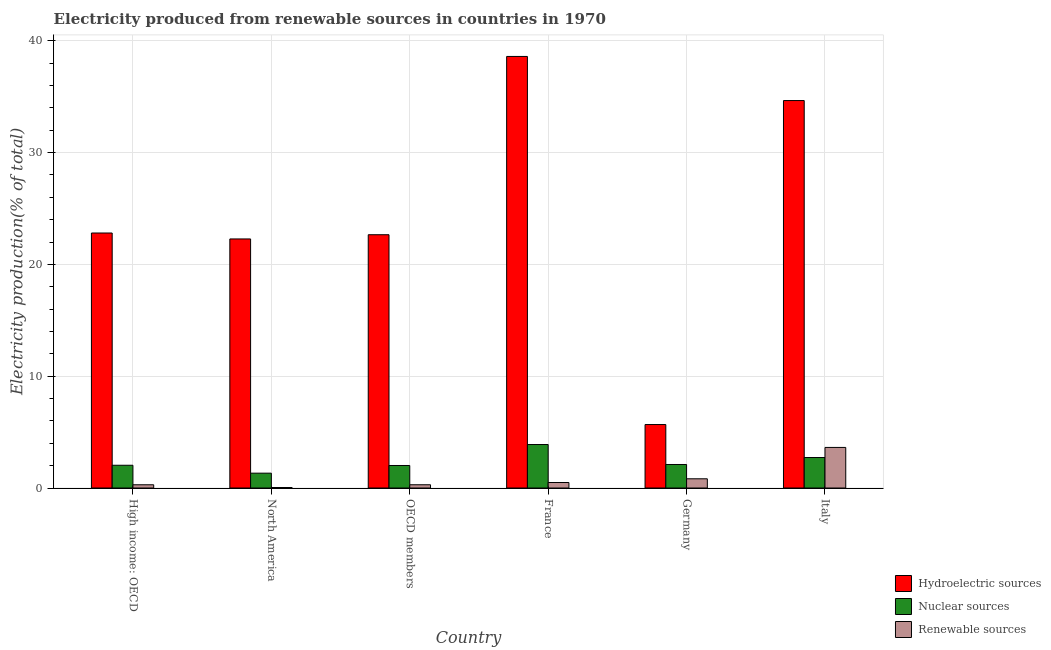How many bars are there on the 6th tick from the left?
Provide a succinct answer. 3. How many bars are there on the 1st tick from the right?
Your answer should be compact. 3. What is the label of the 4th group of bars from the left?
Provide a short and direct response. France. What is the percentage of electricity produced by hydroelectric sources in Germany?
Your answer should be compact. 5.68. Across all countries, what is the maximum percentage of electricity produced by nuclear sources?
Make the answer very short. 3.89. Across all countries, what is the minimum percentage of electricity produced by renewable sources?
Give a very brief answer. 0.04. In which country was the percentage of electricity produced by renewable sources minimum?
Offer a very short reply. North America. What is the total percentage of electricity produced by hydroelectric sources in the graph?
Provide a short and direct response. 146.67. What is the difference between the percentage of electricity produced by nuclear sources in Germany and that in High income: OECD?
Ensure brevity in your answer.  0.07. What is the difference between the percentage of electricity produced by nuclear sources in High income: OECD and the percentage of electricity produced by renewable sources in France?
Your answer should be very brief. 1.54. What is the average percentage of electricity produced by hydroelectric sources per country?
Ensure brevity in your answer.  24.45. What is the difference between the percentage of electricity produced by hydroelectric sources and percentage of electricity produced by renewable sources in High income: OECD?
Provide a succinct answer. 22.52. What is the ratio of the percentage of electricity produced by nuclear sources in France to that in Germany?
Your answer should be very brief. 1.85. Is the percentage of electricity produced by hydroelectric sources in Germany less than that in OECD members?
Ensure brevity in your answer.  Yes. Is the difference between the percentage of electricity produced by hydroelectric sources in France and OECD members greater than the difference between the percentage of electricity produced by nuclear sources in France and OECD members?
Ensure brevity in your answer.  Yes. What is the difference between the highest and the second highest percentage of electricity produced by renewable sources?
Your answer should be very brief. 2.81. What is the difference between the highest and the lowest percentage of electricity produced by hydroelectric sources?
Offer a terse response. 32.92. What does the 3rd bar from the left in High income: OECD represents?
Your answer should be compact. Renewable sources. What does the 2nd bar from the right in Germany represents?
Provide a short and direct response. Nuclear sources. Is it the case that in every country, the sum of the percentage of electricity produced by hydroelectric sources and percentage of electricity produced by nuclear sources is greater than the percentage of electricity produced by renewable sources?
Provide a succinct answer. Yes. How many bars are there?
Your answer should be very brief. 18. How many countries are there in the graph?
Provide a short and direct response. 6. Does the graph contain grids?
Provide a succinct answer. Yes. Where does the legend appear in the graph?
Your response must be concise. Bottom right. How many legend labels are there?
Provide a succinct answer. 3. What is the title of the graph?
Provide a short and direct response. Electricity produced from renewable sources in countries in 1970. Does "Resident buildings and public services" appear as one of the legend labels in the graph?
Your answer should be compact. No. What is the label or title of the Y-axis?
Offer a terse response. Electricity production(% of total). What is the Electricity production(% of total) in Hydroelectric sources in High income: OECD?
Your answer should be very brief. 22.81. What is the Electricity production(% of total) in Nuclear sources in High income: OECD?
Provide a short and direct response. 2.03. What is the Electricity production(% of total) in Renewable sources in High income: OECD?
Ensure brevity in your answer.  0.29. What is the Electricity production(% of total) in Hydroelectric sources in North America?
Offer a very short reply. 22.28. What is the Electricity production(% of total) of Nuclear sources in North America?
Provide a short and direct response. 1.33. What is the Electricity production(% of total) in Renewable sources in North America?
Your answer should be compact. 0.04. What is the Electricity production(% of total) in Hydroelectric sources in OECD members?
Give a very brief answer. 22.65. What is the Electricity production(% of total) of Nuclear sources in OECD members?
Provide a short and direct response. 2.01. What is the Electricity production(% of total) in Renewable sources in OECD members?
Ensure brevity in your answer.  0.29. What is the Electricity production(% of total) in Hydroelectric sources in France?
Offer a terse response. 38.6. What is the Electricity production(% of total) of Nuclear sources in France?
Offer a terse response. 3.89. What is the Electricity production(% of total) of Renewable sources in France?
Offer a terse response. 0.49. What is the Electricity production(% of total) of Hydroelectric sources in Germany?
Your answer should be very brief. 5.68. What is the Electricity production(% of total) in Nuclear sources in Germany?
Provide a succinct answer. 2.1. What is the Electricity production(% of total) of Renewable sources in Germany?
Ensure brevity in your answer.  0.82. What is the Electricity production(% of total) of Hydroelectric sources in Italy?
Keep it short and to the point. 34.66. What is the Electricity production(% of total) in Nuclear sources in Italy?
Your answer should be very brief. 2.73. What is the Electricity production(% of total) of Renewable sources in Italy?
Ensure brevity in your answer.  3.63. Across all countries, what is the maximum Electricity production(% of total) of Hydroelectric sources?
Make the answer very short. 38.6. Across all countries, what is the maximum Electricity production(% of total) of Nuclear sources?
Keep it short and to the point. 3.89. Across all countries, what is the maximum Electricity production(% of total) in Renewable sources?
Your answer should be compact. 3.63. Across all countries, what is the minimum Electricity production(% of total) of Hydroelectric sources?
Your answer should be compact. 5.68. Across all countries, what is the minimum Electricity production(% of total) of Nuclear sources?
Provide a short and direct response. 1.33. Across all countries, what is the minimum Electricity production(% of total) of Renewable sources?
Your answer should be very brief. 0.04. What is the total Electricity production(% of total) of Hydroelectric sources in the graph?
Offer a very short reply. 146.67. What is the total Electricity production(% of total) in Nuclear sources in the graph?
Provide a short and direct response. 14.1. What is the total Electricity production(% of total) in Renewable sources in the graph?
Offer a terse response. 5.57. What is the difference between the Electricity production(% of total) of Hydroelectric sources in High income: OECD and that in North America?
Give a very brief answer. 0.53. What is the difference between the Electricity production(% of total) of Nuclear sources in High income: OECD and that in North America?
Provide a succinct answer. 0.71. What is the difference between the Electricity production(% of total) in Renewable sources in High income: OECD and that in North America?
Provide a short and direct response. 0.24. What is the difference between the Electricity production(% of total) of Hydroelectric sources in High income: OECD and that in OECD members?
Offer a terse response. 0.15. What is the difference between the Electricity production(% of total) in Nuclear sources in High income: OECD and that in OECD members?
Make the answer very short. 0.02. What is the difference between the Electricity production(% of total) of Renewable sources in High income: OECD and that in OECD members?
Offer a terse response. -0. What is the difference between the Electricity production(% of total) in Hydroelectric sources in High income: OECD and that in France?
Your answer should be compact. -15.79. What is the difference between the Electricity production(% of total) of Nuclear sources in High income: OECD and that in France?
Your answer should be very brief. -1.86. What is the difference between the Electricity production(% of total) in Renewable sources in High income: OECD and that in France?
Keep it short and to the point. -0.2. What is the difference between the Electricity production(% of total) of Hydroelectric sources in High income: OECD and that in Germany?
Make the answer very short. 17.13. What is the difference between the Electricity production(% of total) of Nuclear sources in High income: OECD and that in Germany?
Your answer should be very brief. -0.07. What is the difference between the Electricity production(% of total) of Renewable sources in High income: OECD and that in Germany?
Ensure brevity in your answer.  -0.53. What is the difference between the Electricity production(% of total) of Hydroelectric sources in High income: OECD and that in Italy?
Offer a terse response. -11.85. What is the difference between the Electricity production(% of total) of Nuclear sources in High income: OECD and that in Italy?
Offer a terse response. -0.69. What is the difference between the Electricity production(% of total) in Renewable sources in High income: OECD and that in Italy?
Give a very brief answer. -3.34. What is the difference between the Electricity production(% of total) of Hydroelectric sources in North America and that in OECD members?
Your response must be concise. -0.38. What is the difference between the Electricity production(% of total) in Nuclear sources in North America and that in OECD members?
Offer a very short reply. -0.69. What is the difference between the Electricity production(% of total) in Renewable sources in North America and that in OECD members?
Provide a short and direct response. -0.25. What is the difference between the Electricity production(% of total) in Hydroelectric sources in North America and that in France?
Provide a short and direct response. -16.32. What is the difference between the Electricity production(% of total) in Nuclear sources in North America and that in France?
Ensure brevity in your answer.  -2.56. What is the difference between the Electricity production(% of total) in Renewable sources in North America and that in France?
Your answer should be compact. -0.45. What is the difference between the Electricity production(% of total) of Hydroelectric sources in North America and that in Germany?
Offer a very short reply. 16.6. What is the difference between the Electricity production(% of total) in Nuclear sources in North America and that in Germany?
Provide a succinct answer. -0.78. What is the difference between the Electricity production(% of total) of Renewable sources in North America and that in Germany?
Offer a terse response. -0.78. What is the difference between the Electricity production(% of total) of Hydroelectric sources in North America and that in Italy?
Provide a short and direct response. -12.38. What is the difference between the Electricity production(% of total) in Nuclear sources in North America and that in Italy?
Offer a terse response. -1.4. What is the difference between the Electricity production(% of total) of Renewable sources in North America and that in Italy?
Keep it short and to the point. -3.58. What is the difference between the Electricity production(% of total) of Hydroelectric sources in OECD members and that in France?
Your answer should be very brief. -15.95. What is the difference between the Electricity production(% of total) of Nuclear sources in OECD members and that in France?
Offer a very short reply. -1.88. What is the difference between the Electricity production(% of total) in Renewable sources in OECD members and that in France?
Offer a very short reply. -0.2. What is the difference between the Electricity production(% of total) of Hydroelectric sources in OECD members and that in Germany?
Your answer should be very brief. 16.98. What is the difference between the Electricity production(% of total) in Nuclear sources in OECD members and that in Germany?
Offer a terse response. -0.09. What is the difference between the Electricity production(% of total) of Renewable sources in OECD members and that in Germany?
Give a very brief answer. -0.53. What is the difference between the Electricity production(% of total) in Hydroelectric sources in OECD members and that in Italy?
Your response must be concise. -12. What is the difference between the Electricity production(% of total) in Nuclear sources in OECD members and that in Italy?
Ensure brevity in your answer.  -0.71. What is the difference between the Electricity production(% of total) in Renewable sources in OECD members and that in Italy?
Your response must be concise. -3.34. What is the difference between the Electricity production(% of total) of Hydroelectric sources in France and that in Germany?
Ensure brevity in your answer.  32.92. What is the difference between the Electricity production(% of total) in Nuclear sources in France and that in Germany?
Ensure brevity in your answer.  1.79. What is the difference between the Electricity production(% of total) of Renewable sources in France and that in Germany?
Your answer should be very brief. -0.33. What is the difference between the Electricity production(% of total) of Hydroelectric sources in France and that in Italy?
Offer a very short reply. 3.94. What is the difference between the Electricity production(% of total) of Nuclear sources in France and that in Italy?
Your answer should be very brief. 1.16. What is the difference between the Electricity production(% of total) of Renewable sources in France and that in Italy?
Give a very brief answer. -3.14. What is the difference between the Electricity production(% of total) of Hydroelectric sources in Germany and that in Italy?
Ensure brevity in your answer.  -28.98. What is the difference between the Electricity production(% of total) of Nuclear sources in Germany and that in Italy?
Offer a terse response. -0.62. What is the difference between the Electricity production(% of total) of Renewable sources in Germany and that in Italy?
Keep it short and to the point. -2.81. What is the difference between the Electricity production(% of total) in Hydroelectric sources in High income: OECD and the Electricity production(% of total) in Nuclear sources in North America?
Ensure brevity in your answer.  21.48. What is the difference between the Electricity production(% of total) of Hydroelectric sources in High income: OECD and the Electricity production(% of total) of Renewable sources in North America?
Offer a very short reply. 22.76. What is the difference between the Electricity production(% of total) of Nuclear sources in High income: OECD and the Electricity production(% of total) of Renewable sources in North America?
Make the answer very short. 1.99. What is the difference between the Electricity production(% of total) in Hydroelectric sources in High income: OECD and the Electricity production(% of total) in Nuclear sources in OECD members?
Make the answer very short. 20.79. What is the difference between the Electricity production(% of total) of Hydroelectric sources in High income: OECD and the Electricity production(% of total) of Renewable sources in OECD members?
Your response must be concise. 22.52. What is the difference between the Electricity production(% of total) in Nuclear sources in High income: OECD and the Electricity production(% of total) in Renewable sources in OECD members?
Make the answer very short. 1.74. What is the difference between the Electricity production(% of total) in Hydroelectric sources in High income: OECD and the Electricity production(% of total) in Nuclear sources in France?
Make the answer very short. 18.92. What is the difference between the Electricity production(% of total) in Hydroelectric sources in High income: OECD and the Electricity production(% of total) in Renewable sources in France?
Offer a terse response. 22.32. What is the difference between the Electricity production(% of total) of Nuclear sources in High income: OECD and the Electricity production(% of total) of Renewable sources in France?
Keep it short and to the point. 1.54. What is the difference between the Electricity production(% of total) in Hydroelectric sources in High income: OECD and the Electricity production(% of total) in Nuclear sources in Germany?
Provide a succinct answer. 20.7. What is the difference between the Electricity production(% of total) in Hydroelectric sources in High income: OECD and the Electricity production(% of total) in Renewable sources in Germany?
Offer a very short reply. 21.98. What is the difference between the Electricity production(% of total) of Nuclear sources in High income: OECD and the Electricity production(% of total) of Renewable sources in Germany?
Offer a terse response. 1.21. What is the difference between the Electricity production(% of total) in Hydroelectric sources in High income: OECD and the Electricity production(% of total) in Nuclear sources in Italy?
Make the answer very short. 20.08. What is the difference between the Electricity production(% of total) of Hydroelectric sources in High income: OECD and the Electricity production(% of total) of Renewable sources in Italy?
Provide a short and direct response. 19.18. What is the difference between the Electricity production(% of total) in Nuclear sources in High income: OECD and the Electricity production(% of total) in Renewable sources in Italy?
Offer a terse response. -1.59. What is the difference between the Electricity production(% of total) in Hydroelectric sources in North America and the Electricity production(% of total) in Nuclear sources in OECD members?
Keep it short and to the point. 20.26. What is the difference between the Electricity production(% of total) of Hydroelectric sources in North America and the Electricity production(% of total) of Renewable sources in OECD members?
Your response must be concise. 21.99. What is the difference between the Electricity production(% of total) in Nuclear sources in North America and the Electricity production(% of total) in Renewable sources in OECD members?
Give a very brief answer. 1.04. What is the difference between the Electricity production(% of total) in Hydroelectric sources in North America and the Electricity production(% of total) in Nuclear sources in France?
Provide a succinct answer. 18.39. What is the difference between the Electricity production(% of total) of Hydroelectric sources in North America and the Electricity production(% of total) of Renewable sources in France?
Offer a very short reply. 21.79. What is the difference between the Electricity production(% of total) in Nuclear sources in North America and the Electricity production(% of total) in Renewable sources in France?
Ensure brevity in your answer.  0.84. What is the difference between the Electricity production(% of total) of Hydroelectric sources in North America and the Electricity production(% of total) of Nuclear sources in Germany?
Offer a very short reply. 20.17. What is the difference between the Electricity production(% of total) in Hydroelectric sources in North America and the Electricity production(% of total) in Renewable sources in Germany?
Ensure brevity in your answer.  21.45. What is the difference between the Electricity production(% of total) in Nuclear sources in North America and the Electricity production(% of total) in Renewable sources in Germany?
Offer a very short reply. 0.5. What is the difference between the Electricity production(% of total) of Hydroelectric sources in North America and the Electricity production(% of total) of Nuclear sources in Italy?
Provide a short and direct response. 19.55. What is the difference between the Electricity production(% of total) of Hydroelectric sources in North America and the Electricity production(% of total) of Renewable sources in Italy?
Your response must be concise. 18.65. What is the difference between the Electricity production(% of total) of Nuclear sources in North America and the Electricity production(% of total) of Renewable sources in Italy?
Keep it short and to the point. -2.3. What is the difference between the Electricity production(% of total) in Hydroelectric sources in OECD members and the Electricity production(% of total) in Nuclear sources in France?
Your answer should be compact. 18.76. What is the difference between the Electricity production(% of total) of Hydroelectric sources in OECD members and the Electricity production(% of total) of Renewable sources in France?
Provide a short and direct response. 22.16. What is the difference between the Electricity production(% of total) in Nuclear sources in OECD members and the Electricity production(% of total) in Renewable sources in France?
Your answer should be compact. 1.52. What is the difference between the Electricity production(% of total) in Hydroelectric sources in OECD members and the Electricity production(% of total) in Nuclear sources in Germany?
Give a very brief answer. 20.55. What is the difference between the Electricity production(% of total) in Hydroelectric sources in OECD members and the Electricity production(% of total) in Renewable sources in Germany?
Your answer should be compact. 21.83. What is the difference between the Electricity production(% of total) in Nuclear sources in OECD members and the Electricity production(% of total) in Renewable sources in Germany?
Offer a very short reply. 1.19. What is the difference between the Electricity production(% of total) of Hydroelectric sources in OECD members and the Electricity production(% of total) of Nuclear sources in Italy?
Offer a very short reply. 19.93. What is the difference between the Electricity production(% of total) of Hydroelectric sources in OECD members and the Electricity production(% of total) of Renewable sources in Italy?
Keep it short and to the point. 19.03. What is the difference between the Electricity production(% of total) of Nuclear sources in OECD members and the Electricity production(% of total) of Renewable sources in Italy?
Offer a terse response. -1.62. What is the difference between the Electricity production(% of total) in Hydroelectric sources in France and the Electricity production(% of total) in Nuclear sources in Germany?
Your response must be concise. 36.5. What is the difference between the Electricity production(% of total) in Hydroelectric sources in France and the Electricity production(% of total) in Renewable sources in Germany?
Your answer should be compact. 37.78. What is the difference between the Electricity production(% of total) in Nuclear sources in France and the Electricity production(% of total) in Renewable sources in Germany?
Provide a succinct answer. 3.07. What is the difference between the Electricity production(% of total) in Hydroelectric sources in France and the Electricity production(% of total) in Nuclear sources in Italy?
Offer a very short reply. 35.87. What is the difference between the Electricity production(% of total) in Hydroelectric sources in France and the Electricity production(% of total) in Renewable sources in Italy?
Provide a short and direct response. 34.97. What is the difference between the Electricity production(% of total) of Nuclear sources in France and the Electricity production(% of total) of Renewable sources in Italy?
Offer a terse response. 0.26. What is the difference between the Electricity production(% of total) in Hydroelectric sources in Germany and the Electricity production(% of total) in Nuclear sources in Italy?
Your answer should be compact. 2.95. What is the difference between the Electricity production(% of total) of Hydroelectric sources in Germany and the Electricity production(% of total) of Renewable sources in Italy?
Your answer should be compact. 2.05. What is the difference between the Electricity production(% of total) of Nuclear sources in Germany and the Electricity production(% of total) of Renewable sources in Italy?
Provide a short and direct response. -1.53. What is the average Electricity production(% of total) in Hydroelectric sources per country?
Your response must be concise. 24.45. What is the average Electricity production(% of total) in Nuclear sources per country?
Ensure brevity in your answer.  2.35. What is the average Electricity production(% of total) in Renewable sources per country?
Make the answer very short. 0.93. What is the difference between the Electricity production(% of total) of Hydroelectric sources and Electricity production(% of total) of Nuclear sources in High income: OECD?
Offer a terse response. 20.77. What is the difference between the Electricity production(% of total) of Hydroelectric sources and Electricity production(% of total) of Renewable sources in High income: OECD?
Make the answer very short. 22.52. What is the difference between the Electricity production(% of total) in Nuclear sources and Electricity production(% of total) in Renewable sources in High income: OECD?
Your response must be concise. 1.75. What is the difference between the Electricity production(% of total) in Hydroelectric sources and Electricity production(% of total) in Nuclear sources in North America?
Provide a succinct answer. 20.95. What is the difference between the Electricity production(% of total) in Hydroelectric sources and Electricity production(% of total) in Renewable sources in North America?
Offer a very short reply. 22.23. What is the difference between the Electricity production(% of total) of Nuclear sources and Electricity production(% of total) of Renewable sources in North America?
Provide a short and direct response. 1.28. What is the difference between the Electricity production(% of total) in Hydroelectric sources and Electricity production(% of total) in Nuclear sources in OECD members?
Ensure brevity in your answer.  20.64. What is the difference between the Electricity production(% of total) of Hydroelectric sources and Electricity production(% of total) of Renewable sources in OECD members?
Provide a short and direct response. 22.36. What is the difference between the Electricity production(% of total) of Nuclear sources and Electricity production(% of total) of Renewable sources in OECD members?
Your response must be concise. 1.72. What is the difference between the Electricity production(% of total) in Hydroelectric sources and Electricity production(% of total) in Nuclear sources in France?
Offer a terse response. 34.71. What is the difference between the Electricity production(% of total) in Hydroelectric sources and Electricity production(% of total) in Renewable sources in France?
Give a very brief answer. 38.11. What is the difference between the Electricity production(% of total) of Nuclear sources and Electricity production(% of total) of Renewable sources in France?
Provide a short and direct response. 3.4. What is the difference between the Electricity production(% of total) of Hydroelectric sources and Electricity production(% of total) of Nuclear sources in Germany?
Keep it short and to the point. 3.57. What is the difference between the Electricity production(% of total) of Hydroelectric sources and Electricity production(% of total) of Renewable sources in Germany?
Give a very brief answer. 4.85. What is the difference between the Electricity production(% of total) of Nuclear sources and Electricity production(% of total) of Renewable sources in Germany?
Provide a short and direct response. 1.28. What is the difference between the Electricity production(% of total) of Hydroelectric sources and Electricity production(% of total) of Nuclear sources in Italy?
Give a very brief answer. 31.93. What is the difference between the Electricity production(% of total) of Hydroelectric sources and Electricity production(% of total) of Renewable sources in Italy?
Your answer should be very brief. 31.03. What is the difference between the Electricity production(% of total) in Nuclear sources and Electricity production(% of total) in Renewable sources in Italy?
Your answer should be compact. -0.9. What is the ratio of the Electricity production(% of total) in Hydroelectric sources in High income: OECD to that in North America?
Offer a very short reply. 1.02. What is the ratio of the Electricity production(% of total) of Nuclear sources in High income: OECD to that in North America?
Keep it short and to the point. 1.53. What is the ratio of the Electricity production(% of total) of Renewable sources in High income: OECD to that in North America?
Give a very brief answer. 6.5. What is the ratio of the Electricity production(% of total) of Hydroelectric sources in High income: OECD to that in OECD members?
Offer a very short reply. 1.01. What is the ratio of the Electricity production(% of total) in Nuclear sources in High income: OECD to that in OECD members?
Your response must be concise. 1.01. What is the ratio of the Electricity production(% of total) in Renewable sources in High income: OECD to that in OECD members?
Offer a very short reply. 0.99. What is the ratio of the Electricity production(% of total) of Hydroelectric sources in High income: OECD to that in France?
Offer a very short reply. 0.59. What is the ratio of the Electricity production(% of total) of Nuclear sources in High income: OECD to that in France?
Offer a very short reply. 0.52. What is the ratio of the Electricity production(% of total) of Renewable sources in High income: OECD to that in France?
Ensure brevity in your answer.  0.59. What is the ratio of the Electricity production(% of total) in Hydroelectric sources in High income: OECD to that in Germany?
Give a very brief answer. 4.02. What is the ratio of the Electricity production(% of total) in Nuclear sources in High income: OECD to that in Germany?
Your answer should be compact. 0.97. What is the ratio of the Electricity production(% of total) of Renewable sources in High income: OECD to that in Germany?
Provide a short and direct response. 0.35. What is the ratio of the Electricity production(% of total) in Hydroelectric sources in High income: OECD to that in Italy?
Your response must be concise. 0.66. What is the ratio of the Electricity production(% of total) in Nuclear sources in High income: OECD to that in Italy?
Offer a very short reply. 0.75. What is the ratio of the Electricity production(% of total) of Renewable sources in High income: OECD to that in Italy?
Offer a terse response. 0.08. What is the ratio of the Electricity production(% of total) in Hydroelectric sources in North America to that in OECD members?
Offer a terse response. 0.98. What is the ratio of the Electricity production(% of total) in Nuclear sources in North America to that in OECD members?
Your response must be concise. 0.66. What is the ratio of the Electricity production(% of total) of Renewable sources in North America to that in OECD members?
Offer a terse response. 0.15. What is the ratio of the Electricity production(% of total) in Hydroelectric sources in North America to that in France?
Offer a very short reply. 0.58. What is the ratio of the Electricity production(% of total) of Nuclear sources in North America to that in France?
Provide a succinct answer. 0.34. What is the ratio of the Electricity production(% of total) in Renewable sources in North America to that in France?
Your answer should be very brief. 0.09. What is the ratio of the Electricity production(% of total) of Hydroelectric sources in North America to that in Germany?
Your answer should be very brief. 3.92. What is the ratio of the Electricity production(% of total) in Nuclear sources in North America to that in Germany?
Your answer should be very brief. 0.63. What is the ratio of the Electricity production(% of total) of Renewable sources in North America to that in Germany?
Ensure brevity in your answer.  0.05. What is the ratio of the Electricity production(% of total) of Hydroelectric sources in North America to that in Italy?
Provide a short and direct response. 0.64. What is the ratio of the Electricity production(% of total) in Nuclear sources in North America to that in Italy?
Give a very brief answer. 0.49. What is the ratio of the Electricity production(% of total) of Renewable sources in North America to that in Italy?
Ensure brevity in your answer.  0.01. What is the ratio of the Electricity production(% of total) of Hydroelectric sources in OECD members to that in France?
Give a very brief answer. 0.59. What is the ratio of the Electricity production(% of total) of Nuclear sources in OECD members to that in France?
Give a very brief answer. 0.52. What is the ratio of the Electricity production(% of total) of Renewable sources in OECD members to that in France?
Provide a short and direct response. 0.59. What is the ratio of the Electricity production(% of total) of Hydroelectric sources in OECD members to that in Germany?
Provide a short and direct response. 3.99. What is the ratio of the Electricity production(% of total) in Nuclear sources in OECD members to that in Germany?
Your answer should be compact. 0.96. What is the ratio of the Electricity production(% of total) of Renewable sources in OECD members to that in Germany?
Your answer should be compact. 0.35. What is the ratio of the Electricity production(% of total) in Hydroelectric sources in OECD members to that in Italy?
Provide a short and direct response. 0.65. What is the ratio of the Electricity production(% of total) in Nuclear sources in OECD members to that in Italy?
Make the answer very short. 0.74. What is the ratio of the Electricity production(% of total) of Renewable sources in OECD members to that in Italy?
Your answer should be compact. 0.08. What is the ratio of the Electricity production(% of total) in Hydroelectric sources in France to that in Germany?
Provide a succinct answer. 6.8. What is the ratio of the Electricity production(% of total) of Nuclear sources in France to that in Germany?
Give a very brief answer. 1.85. What is the ratio of the Electricity production(% of total) in Renewable sources in France to that in Germany?
Your answer should be compact. 0.6. What is the ratio of the Electricity production(% of total) of Hydroelectric sources in France to that in Italy?
Provide a succinct answer. 1.11. What is the ratio of the Electricity production(% of total) in Nuclear sources in France to that in Italy?
Give a very brief answer. 1.43. What is the ratio of the Electricity production(% of total) of Renewable sources in France to that in Italy?
Ensure brevity in your answer.  0.14. What is the ratio of the Electricity production(% of total) of Hydroelectric sources in Germany to that in Italy?
Your answer should be very brief. 0.16. What is the ratio of the Electricity production(% of total) in Nuclear sources in Germany to that in Italy?
Your answer should be very brief. 0.77. What is the ratio of the Electricity production(% of total) of Renewable sources in Germany to that in Italy?
Your answer should be very brief. 0.23. What is the difference between the highest and the second highest Electricity production(% of total) of Hydroelectric sources?
Offer a terse response. 3.94. What is the difference between the highest and the second highest Electricity production(% of total) in Nuclear sources?
Provide a short and direct response. 1.16. What is the difference between the highest and the second highest Electricity production(% of total) of Renewable sources?
Your answer should be compact. 2.81. What is the difference between the highest and the lowest Electricity production(% of total) of Hydroelectric sources?
Your answer should be compact. 32.92. What is the difference between the highest and the lowest Electricity production(% of total) in Nuclear sources?
Your answer should be very brief. 2.56. What is the difference between the highest and the lowest Electricity production(% of total) of Renewable sources?
Offer a terse response. 3.58. 